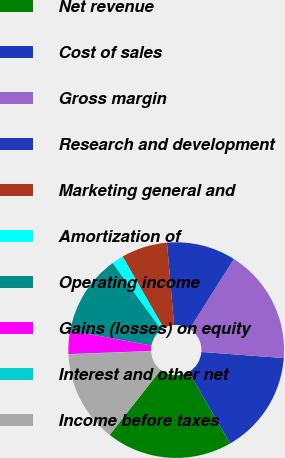Convert chart to OTSL. <chart><loc_0><loc_0><loc_500><loc_500><pie_chart><fcel>Net revenue<fcel>Cost of sales<fcel>Gross margin<fcel>Research and development<fcel>Marketing general and<fcel>Amortization of<fcel>Operating income<fcel>Gains (losses) on equity<fcel>Interest and other net<fcel>Income before taxes<nl><fcel>18.92%<fcel>15.49%<fcel>17.2%<fcel>10.34%<fcel>6.91%<fcel>1.77%<fcel>12.06%<fcel>3.48%<fcel>0.05%<fcel>13.77%<nl></chart> 